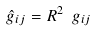<formula> <loc_0><loc_0><loc_500><loc_500>\hat { g } _ { i j } = R ^ { 2 } \ g _ { i j }</formula> 